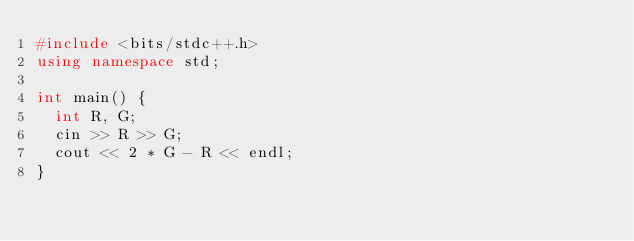Convert code to text. <code><loc_0><loc_0><loc_500><loc_500><_C++_>#include <bits/stdc++.h>
using namespace std;

int main() {
  int R, G;
  cin >> R >> G;
  cout << 2 * G - R << endl;
}</code> 